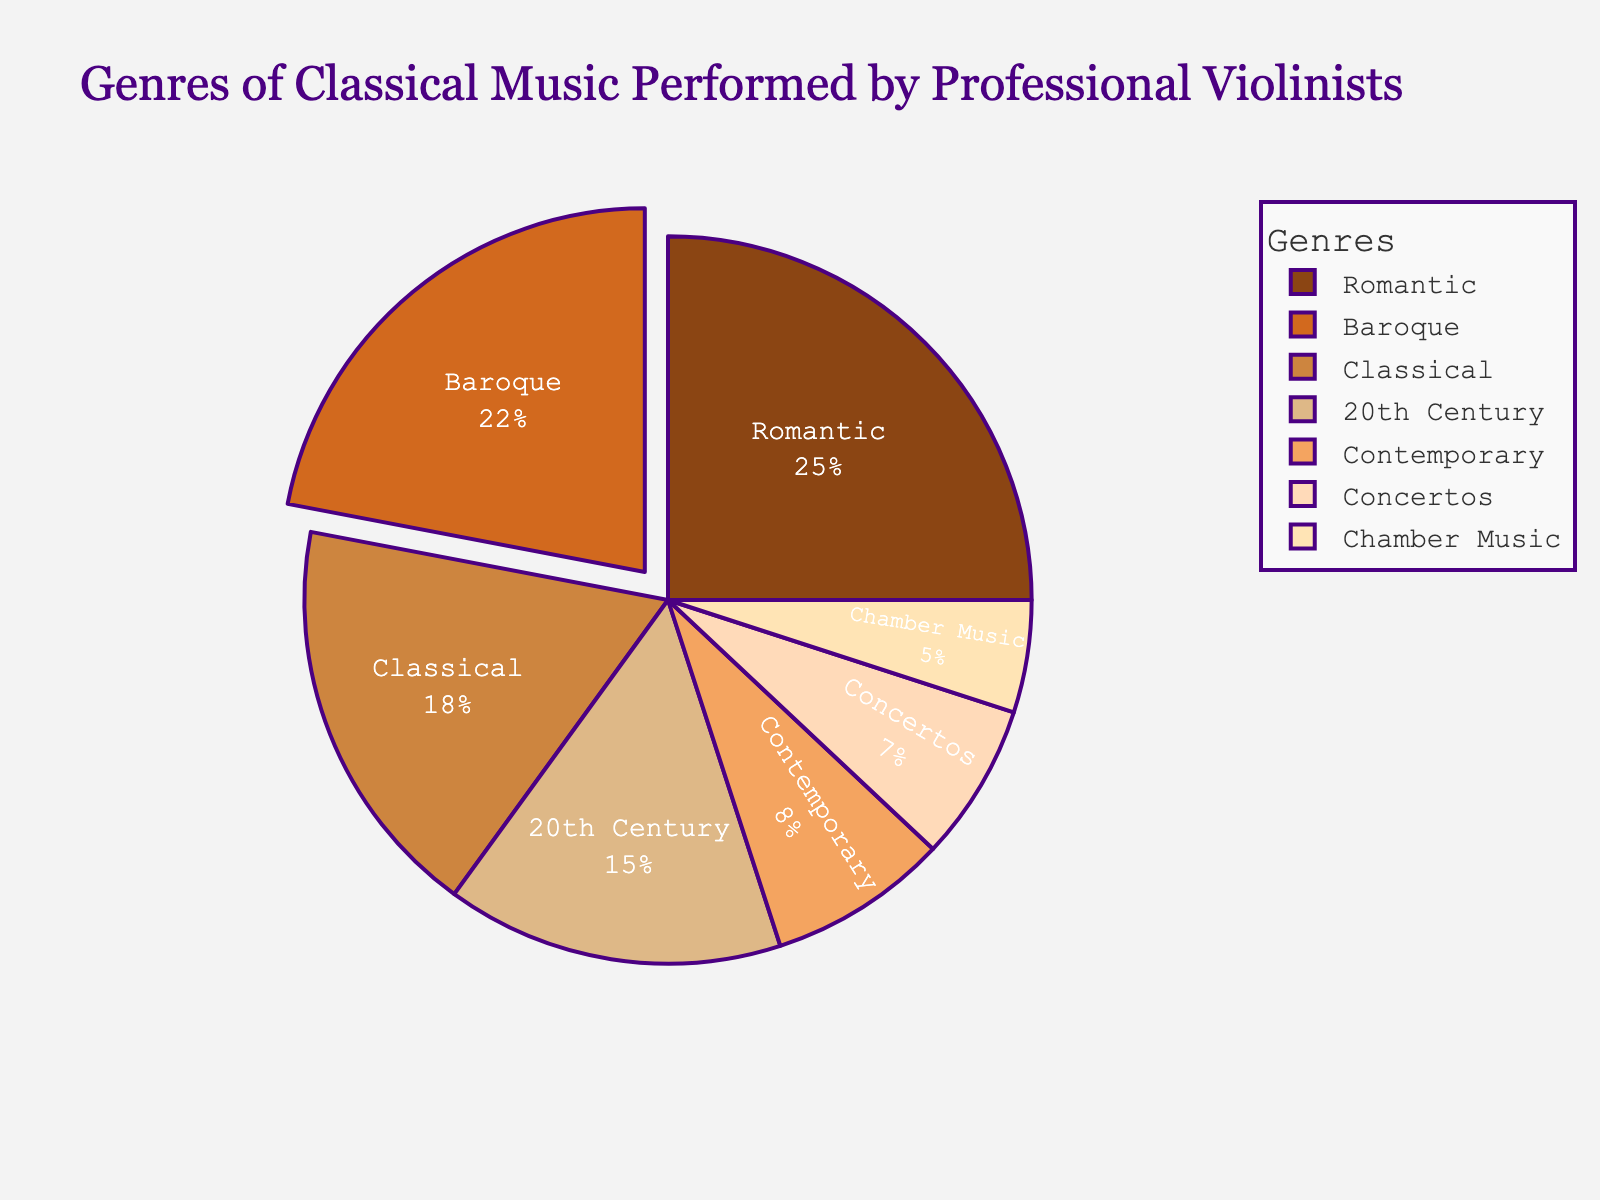What genre occupies the largest slice in the pie chart? The genre occupying the largest slice is the one with the highest percentage. From the data, Romantic has the highest percentage at 25%.
Answer: Romantic Which genres together make up more than 50% of the total? Add the percentages of the largest slices in descending order until the sum exceeds 50%. Romantic (25%) + Baroque (22%) = 47%. Adding Classical (18%) gives 65%. These three together make up more than 50%.
Answer: Romantic, Baroque, Classical What's the difference in percentage between the Romantic and Baroque genres? Subtract the percentage of Baroque from Romantic: 25% - 22% = 3%
Answer: 3% Are there more professional violinists performing 20th Century music or Chamber Music? Compare the percentages of the two genres. 20th Century has 15%, and Chamber Music has 5%. Therefore, more violinists perform 20th Century music.
Answer: 20th Century How does the percentage of Contemporary music compare to Classical music? Compare the percentages of Contemporary and Classical music. Contemporary has 8%, while Classical has 18%.
Answer: Contemporary music is less than Classical music Which genre has a similar percentage to Concertos? From the data, Chamber Music has a percentage close to Concertos. Concertos have 7% and Chamber Music has 5%, which are the closest to each other in the data.
Answer: Chamber Music What is the sum of the percentages for the genres Baroque, Classical, and Contemporary? Add the percentages of Baroque (22%), Classical (18%), and Contemporary (8%). 22% + 18% + 8% = 48%
Answer: 48% Which genre is represented by the color brown in the chart? Look at the custom color palette defined in the code and match it with the genres. The first color in the list (brown) corresponds to Baroque.
Answer: Baroque What is the combined percentage of Concertos and Chamber Music? Add the percentages of Concertos (7%) and Chamber Music (5%). 7% + 5% = 12%
Answer: 12% 